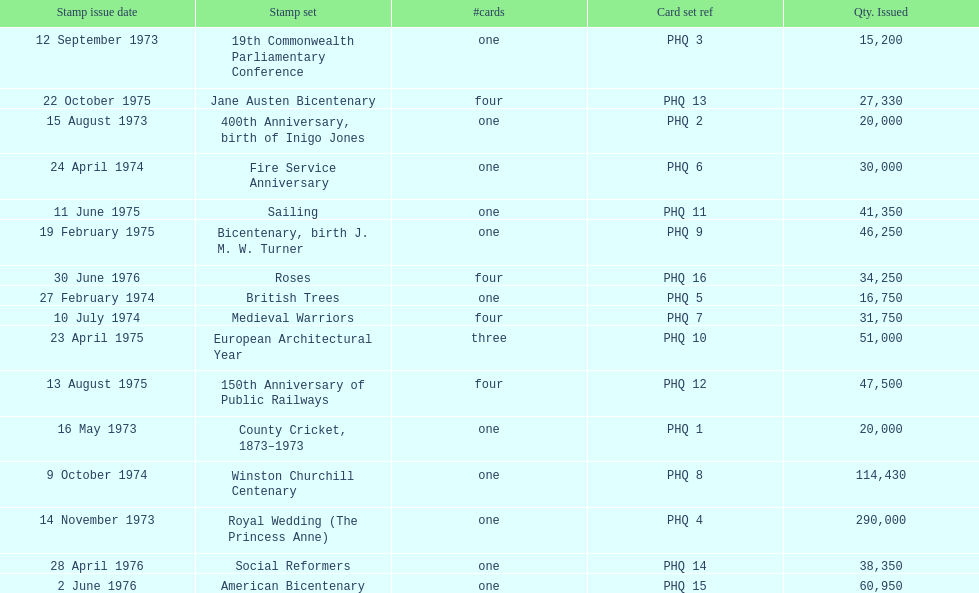Could you help me parse every detail presented in this table? {'header': ['Stamp issue date', 'Stamp set', '#cards', 'Card set ref', 'Qty. Issued'], 'rows': [['12 September 1973', '19th Commonwealth Parliamentary Conference', 'one', 'PHQ 3', '15,200'], ['22 October 1975', 'Jane Austen Bicentenary', 'four', 'PHQ 13', '27,330'], ['15 August 1973', '400th Anniversary, birth of Inigo Jones', 'one', 'PHQ 2', '20,000'], ['24 April 1974', 'Fire Service Anniversary', 'one', 'PHQ 6', '30,000'], ['11 June 1975', 'Sailing', 'one', 'PHQ 11', '41,350'], ['19 February 1975', 'Bicentenary, birth J. M. W. Turner', 'one', 'PHQ 9', '46,250'], ['30 June 1976', 'Roses', 'four', 'PHQ 16', '34,250'], ['27 February 1974', 'British Trees', 'one', 'PHQ 5', '16,750'], ['10 July 1974', 'Medieval Warriors', 'four', 'PHQ 7', '31,750'], ['23 April 1975', 'European Architectural Year', 'three', 'PHQ 10', '51,000'], ['13 August 1975', '150th Anniversary of Public Railways', 'four', 'PHQ 12', '47,500'], ['16 May 1973', 'County Cricket, 1873–1973', 'one', 'PHQ 1', '20,000'], ['9 October 1974', 'Winston Churchill Centenary', 'one', 'PHQ 8', '114,430'], ['14 November 1973', 'Royal Wedding (The Princess Anne)', 'one', 'PHQ 4', '290,000'], ['28 April 1976', 'Social Reformers', 'one', 'PHQ 14', '38,350'], ['2 June 1976', 'American Bicentenary', 'one', 'PHQ 15', '60,950']]} Which card was issued most? Royal Wedding (The Princess Anne). 